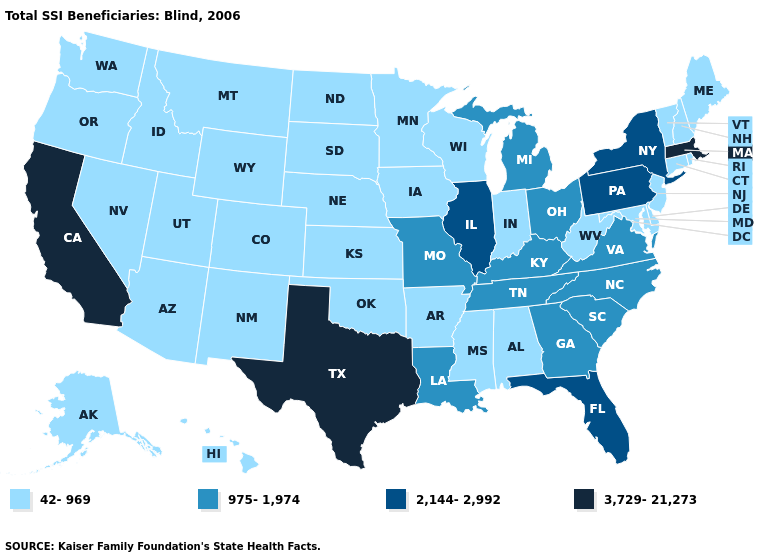Name the states that have a value in the range 3,729-21,273?
Concise answer only. California, Massachusetts, Texas. Name the states that have a value in the range 42-969?
Keep it brief. Alabama, Alaska, Arizona, Arkansas, Colorado, Connecticut, Delaware, Hawaii, Idaho, Indiana, Iowa, Kansas, Maine, Maryland, Minnesota, Mississippi, Montana, Nebraska, Nevada, New Hampshire, New Jersey, New Mexico, North Dakota, Oklahoma, Oregon, Rhode Island, South Dakota, Utah, Vermont, Washington, West Virginia, Wisconsin, Wyoming. Does South Carolina have a lower value than Florida?
Give a very brief answer. Yes. Is the legend a continuous bar?
Give a very brief answer. No. Does Connecticut have the lowest value in the USA?
Answer briefly. Yes. How many symbols are there in the legend?
Short answer required. 4. Which states have the highest value in the USA?
Quick response, please. California, Massachusetts, Texas. Name the states that have a value in the range 3,729-21,273?
Give a very brief answer. California, Massachusetts, Texas. Name the states that have a value in the range 42-969?
Concise answer only. Alabama, Alaska, Arizona, Arkansas, Colorado, Connecticut, Delaware, Hawaii, Idaho, Indiana, Iowa, Kansas, Maine, Maryland, Minnesota, Mississippi, Montana, Nebraska, Nevada, New Hampshire, New Jersey, New Mexico, North Dakota, Oklahoma, Oregon, Rhode Island, South Dakota, Utah, Vermont, Washington, West Virginia, Wisconsin, Wyoming. Among the states that border Tennessee , which have the highest value?
Quick response, please. Georgia, Kentucky, Missouri, North Carolina, Virginia. What is the lowest value in the USA?
Be succinct. 42-969. What is the value of Indiana?
Answer briefly. 42-969. Among the states that border Massachusetts , does Connecticut have the highest value?
Keep it brief. No. Which states have the lowest value in the USA?
Write a very short answer. Alabama, Alaska, Arizona, Arkansas, Colorado, Connecticut, Delaware, Hawaii, Idaho, Indiana, Iowa, Kansas, Maine, Maryland, Minnesota, Mississippi, Montana, Nebraska, Nevada, New Hampshire, New Jersey, New Mexico, North Dakota, Oklahoma, Oregon, Rhode Island, South Dakota, Utah, Vermont, Washington, West Virginia, Wisconsin, Wyoming. Is the legend a continuous bar?
Short answer required. No. 